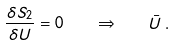Convert formula to latex. <formula><loc_0><loc_0><loc_500><loc_500>\frac { \delta S _ { 2 } } { \delta U } = 0 \quad \Rightarrow \quad \bar { U } \, .</formula> 